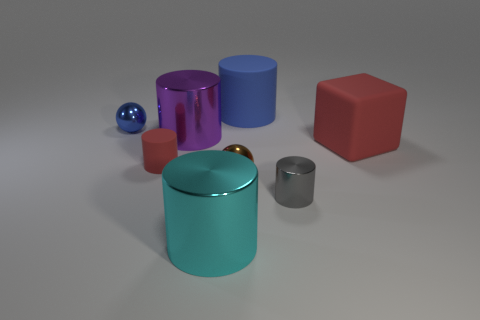Subtract 2 cylinders. How many cylinders are left? 3 Subtract all red cylinders. How many cylinders are left? 4 Subtract all small gray shiny cylinders. How many cylinders are left? 4 Subtract all gray cylinders. Subtract all gray cubes. How many cylinders are left? 4 Add 1 large blue objects. How many objects exist? 9 Subtract all blocks. How many objects are left? 7 Subtract all tiny matte spheres. Subtract all cyan metallic cylinders. How many objects are left? 7 Add 3 small red things. How many small red things are left? 4 Add 3 tiny red things. How many tiny red things exist? 4 Subtract 1 red blocks. How many objects are left? 7 